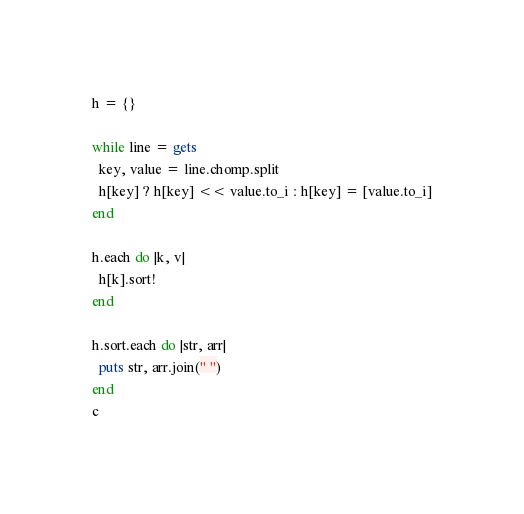<code> <loc_0><loc_0><loc_500><loc_500><_Ruby_>h = {}

while line = gets
  key, value = line.chomp.split
  h[key] ? h[key] << value.to_i : h[key] = [value.to_i]
end

h.each do |k, v|
  h[k].sort!
end

h.sort.each do |str, arr|
  puts str, arr.join(" ")
end
c</code> 